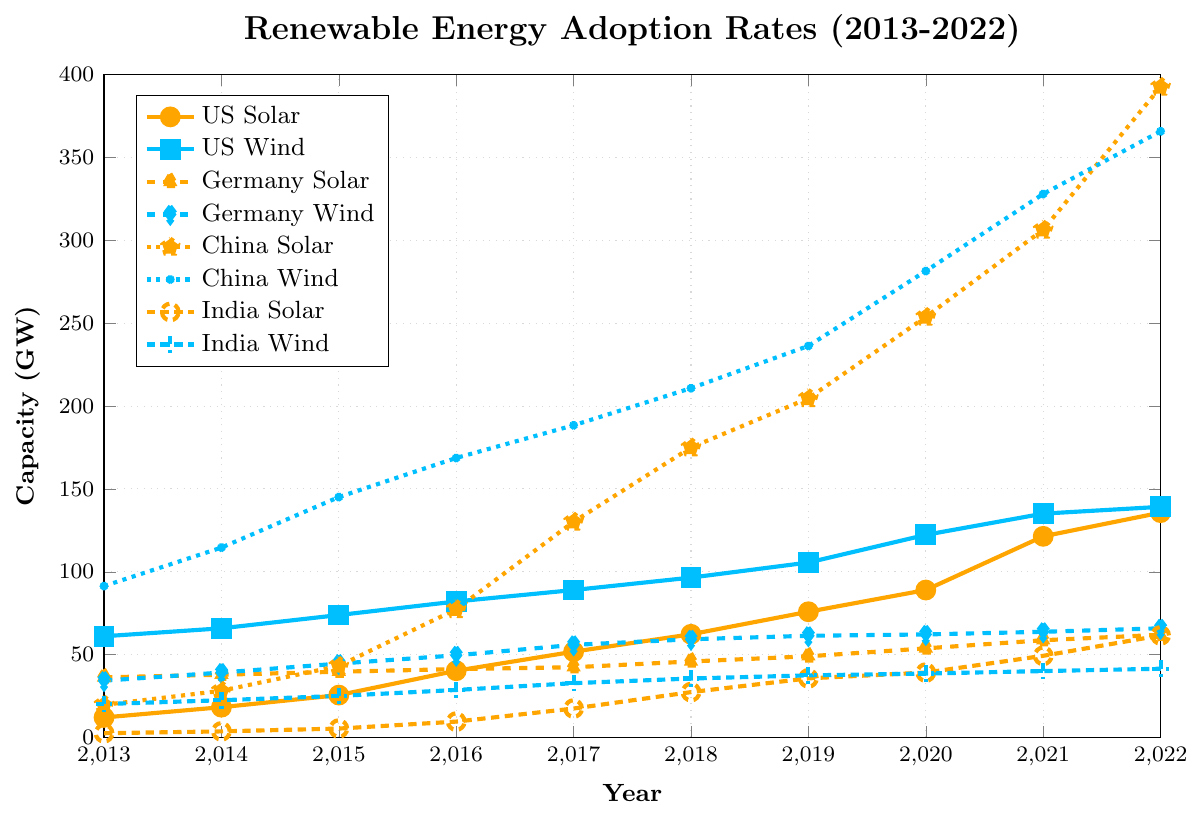What's the overall trend in solar power capacity for China between 2013 and 2022? The solar power capacity for China has shown a dramatic increase from 19.7 GW in 2013 to 392.6 GW in 2022. This indicates a significant upward trend over the decade.
Answer: Significant upward trend Which country had the highest wind power capacity in 2022? Observing the wind power capacity lines for all countries in 2022, China had the highest capacity with 365.8 GW.
Answer: China How much more solar power capacity did Germany have in 2022 compared to 2013? In 2013, Germany had 36.3 GW of solar power capacity, and by 2022, this had increased to 62.0 GW. The difference is 62.0 - 36.3 = 25.7 GW.
Answer: 25.7 GW Between the United States and India, which country had a steeper increase in wind power capacity from 2013 to 2022? The United States increased its wind power capacity from 61.1 GW in 2013 to 139.2 GW in 2022, a difference of 139.2 - 61.1 = 78.1 GW. India increased from 20.2 GW in 2013 to 41.5 GW in 2022, a difference of 41.5 - 20.2 = 21.3 GW. The United States had a steeper increase.
Answer: United States What visual differences can you see between the lines representing solar and wind power in China? The solar line is more remarkably dotted and rises steeply, compared to the wind line which uses star marks and also rises significantly but begins and ends at higher values than solar.
Answer: Dotted line rises steeply for Solar, star marks for Wind Which year did India see the most significant jump in solar power capacity? India saw its most significant jump in solar power capacity between 2016 (9.6 GW) and 2017 (17.5 GW), an increase of 17.5 - 9.6 = 7.9 GW.
Answer: 2017 How did Germany's wind power capacity change from 2013 to 2015? Germany's wind power capacity increased from 34.3 GW in 2013 to 44.6 GW in 2015. The change is 44.6 - 34.3 = 10.3 GW.
Answer: 10.3 GW Compare the average increase in wind power capacity per year between China and Germany from 2013 to 2022. For China, the increase from 91.4 GW to 365.8 GW over 9 years is 365.8 - 91.4 = 274.4 GW, averaging 274.4/9 ≈ 30.5 GW per year. For Germany, the increase from 34.3 GW to 65.9 GW is 65.9 - 34.3 = 31.6 GW, averaging 31.6/9 ≈ 3.5 GW per year. China’s average increase is significantly higher.
Answer: China: ~30.5 GW/year, Germany: ~3.5 GW/year What is the combined solar power capacity of the United States and Germany in 2022? The solar power capacity of the United States in 2022 is 135.7 GW and Germany's is 62.0 GW. Combined, this totals 135.7 + 62.0 = 197.7 GW.
Answer: 197.7 GW 